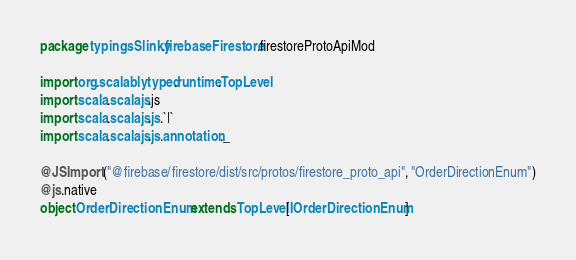<code> <loc_0><loc_0><loc_500><loc_500><_Scala_>package typingsSlinky.firebaseFirestore.firestoreProtoApiMod

import org.scalablytyped.runtime.TopLevel
import scala.scalajs.js
import scala.scalajs.js.`|`
import scala.scalajs.js.annotation._

@JSImport("@firebase/firestore/dist/src/protos/firestore_proto_api", "OrderDirectionEnum")
@js.native
object OrderDirectionEnum extends TopLevel[IOrderDirectionEnum]

</code> 